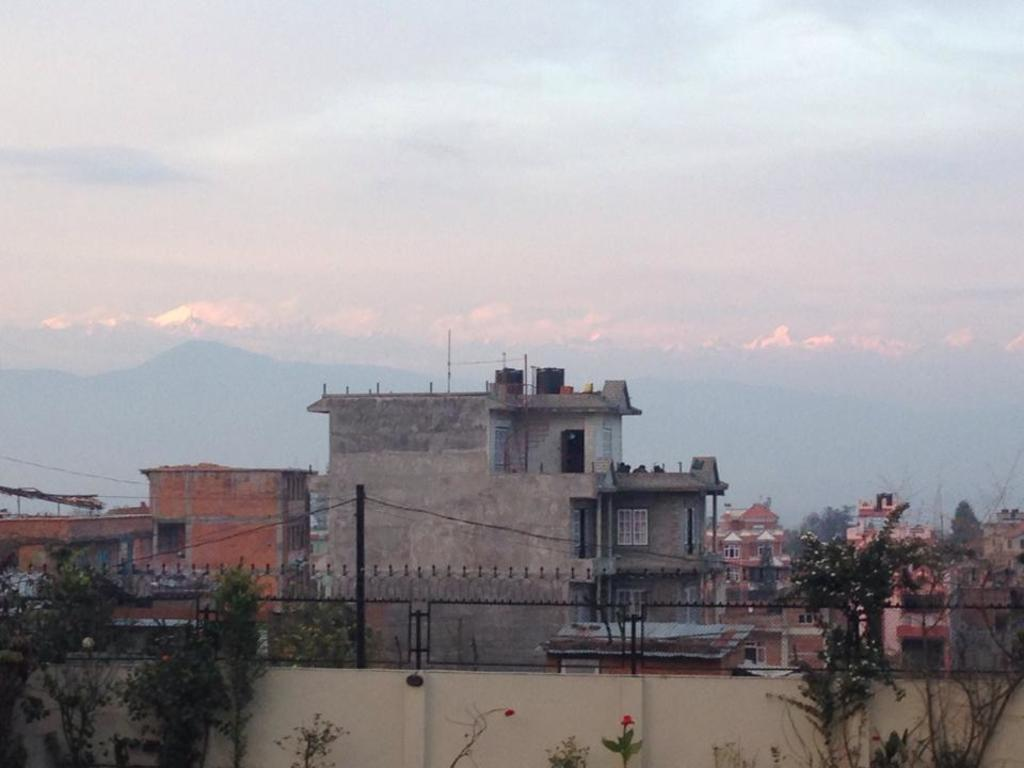What type of structures can be seen in the image? There are buildings in the image. What type of vegetation is present in the image? There are trees and plants in the image. What type of barrier can be seen in the image? There is a wall with a fence in the image in the image. What else can be seen in the image that is related to infrastructure? There is a pole with wires in the image. What part of the natural environment is visible in the image? The sky is visible in the image. Where are the scissors located in the image? There are no scissors present in the image. Who is wearing the crown in the image? There is no crown or person wearing a crown in the image. 